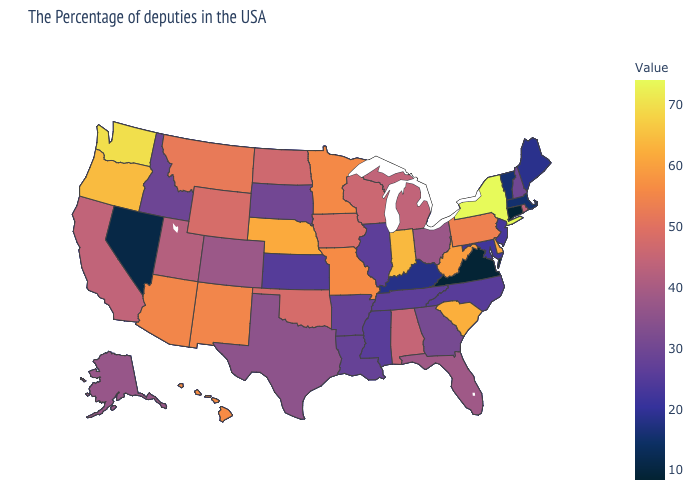Which states have the highest value in the USA?
Be succinct. New York. Does Illinois have a lower value than Connecticut?
Write a very short answer. No. Which states have the lowest value in the USA?
Quick response, please. Connecticut. Which states hav the highest value in the Northeast?
Keep it brief. New York. Is the legend a continuous bar?
Keep it brief. Yes. 